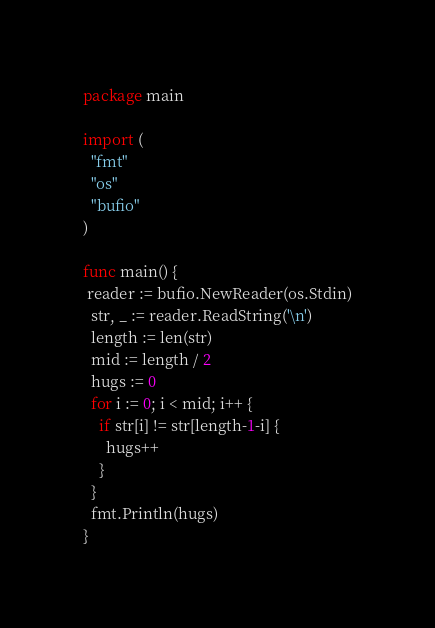<code> <loc_0><loc_0><loc_500><loc_500><_Go_>package main
 
import (
  "fmt"
  "os"
  "bufio"
)
 
func main() {
 reader := bufio.NewReader(os.Stdin)
  str, _ := reader.ReadString('\n')
  length := len(str)
  mid := length / 2
  hugs := 0
  for i := 0; i < mid; i++ {
    if str[i] != str[length-1-i] {
      hugs++
    }
  }
  fmt.Println(hugs)
}</code> 